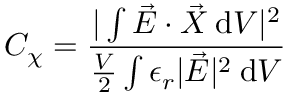<formula> <loc_0><loc_0><loc_500><loc_500>C _ { \chi } = \frac { | \int \vec { E } \cdot \vec { X } \, \mathrm d V | ^ { 2 } } { \frac { V } { 2 } \int \epsilon _ { r } | \vec { E } | ^ { 2 } \, \mathrm d V }</formula> 